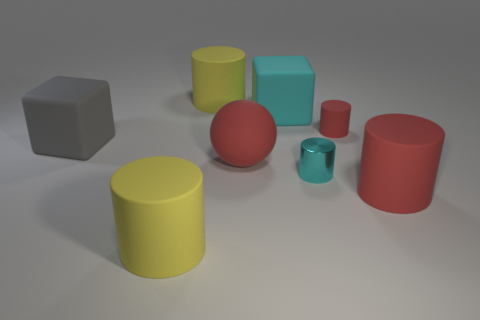Subtract 1 cylinders. How many cylinders are left? 4 Subtract all cyan cylinders. How many cylinders are left? 4 Subtract all cyan cylinders. How many cylinders are left? 4 Add 1 red spheres. How many objects exist? 9 Subtract all brown cylinders. Subtract all blue blocks. How many cylinders are left? 5 Subtract all cubes. How many objects are left? 6 Subtract 0 purple cylinders. How many objects are left? 8 Subtract all large cubes. Subtract all big cyan matte blocks. How many objects are left? 5 Add 3 red things. How many red things are left? 6 Add 2 large brown blocks. How many large brown blocks exist? 2 